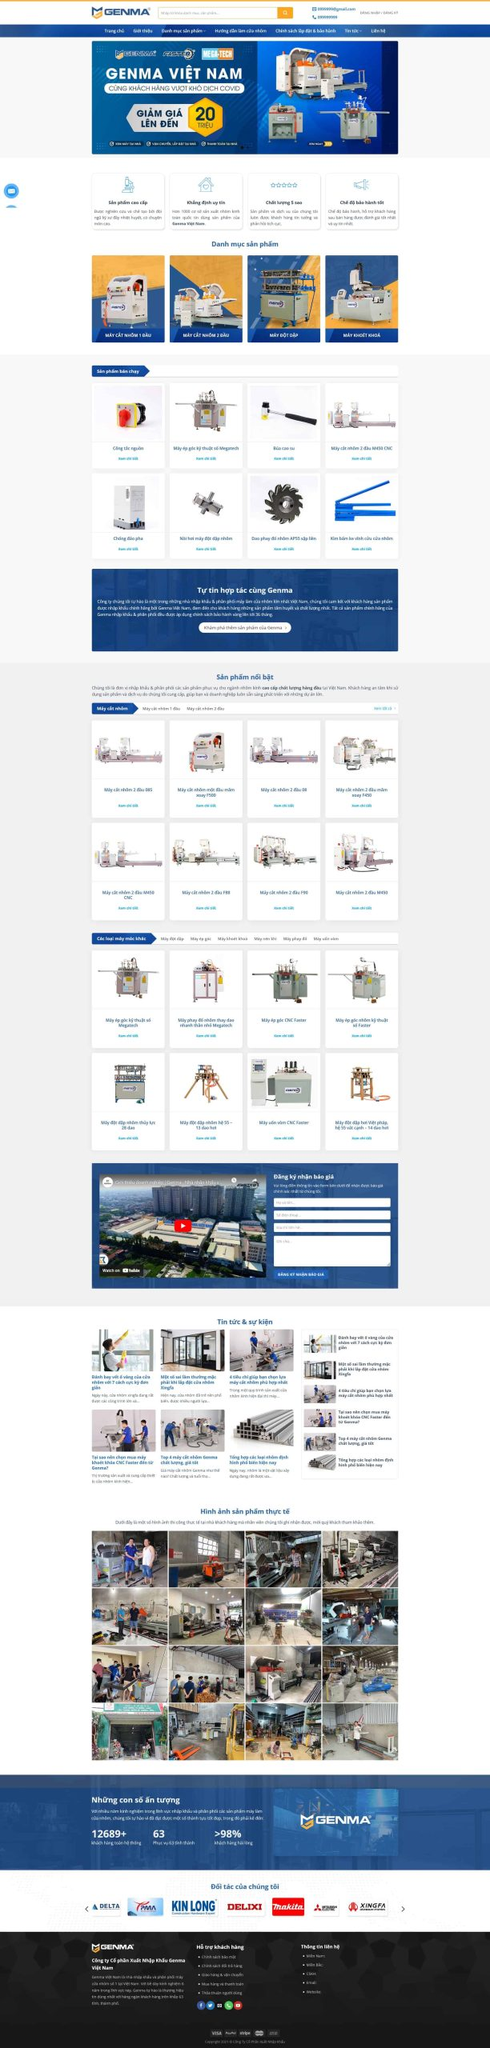Liệt kê 5 ngành nghề, lĩnh vực phù hợp với website này, phân cách các màu sắc bằng dấu phẩy. Chỉ trả về kết quả, phân cách bằng dấy phẩy
 Sản xuất máy móc công nghiệp, Kinh doanh thiết bị cơ khí, Chế tạo và lắp ráp máy móc, Công nghiệp chế tạo kim loại, Thiết bị và dụng cụ tự động hóa 